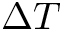Convert formula to latex. <formula><loc_0><loc_0><loc_500><loc_500>\Delta T</formula> 